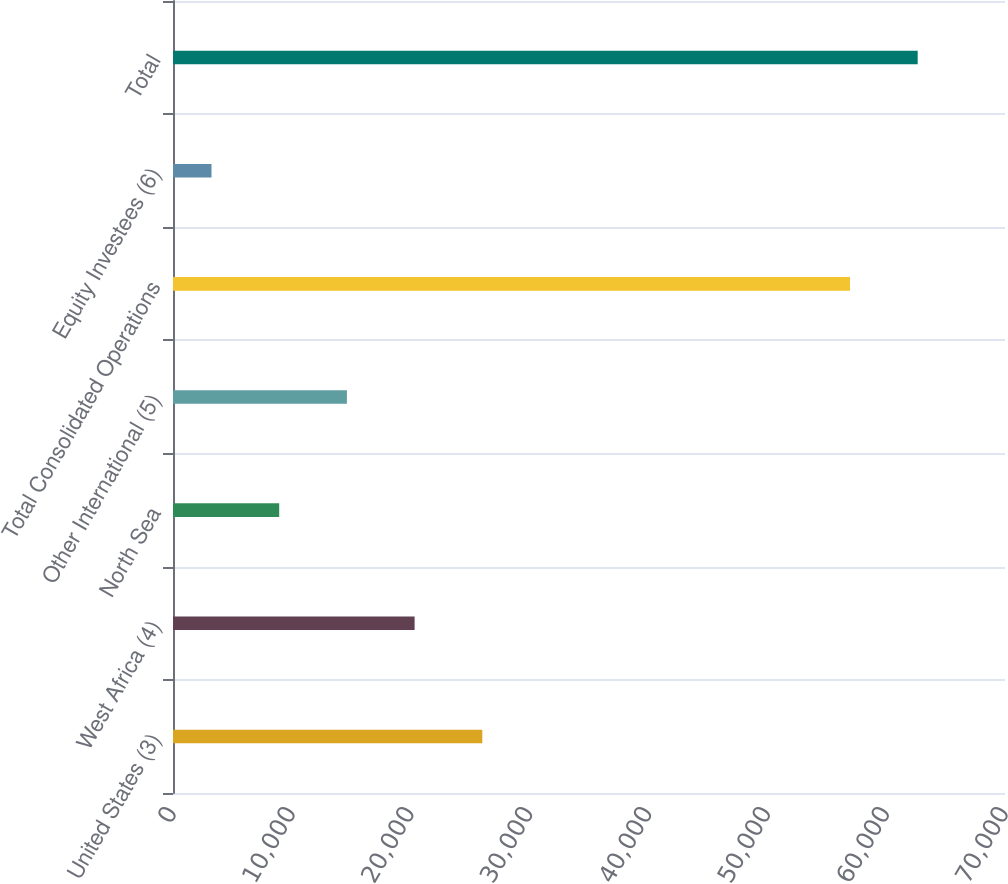<chart> <loc_0><loc_0><loc_500><loc_500><bar_chart><fcel>United States (3)<fcel>West Africa (4)<fcel>North Sea<fcel>Other International (5)<fcel>Total Consolidated Operations<fcel>Equity Investees (6)<fcel>Total<nl><fcel>26023.2<fcel>20327.4<fcel>8935.8<fcel>14631.6<fcel>56958<fcel>3240<fcel>62653.8<nl></chart> 